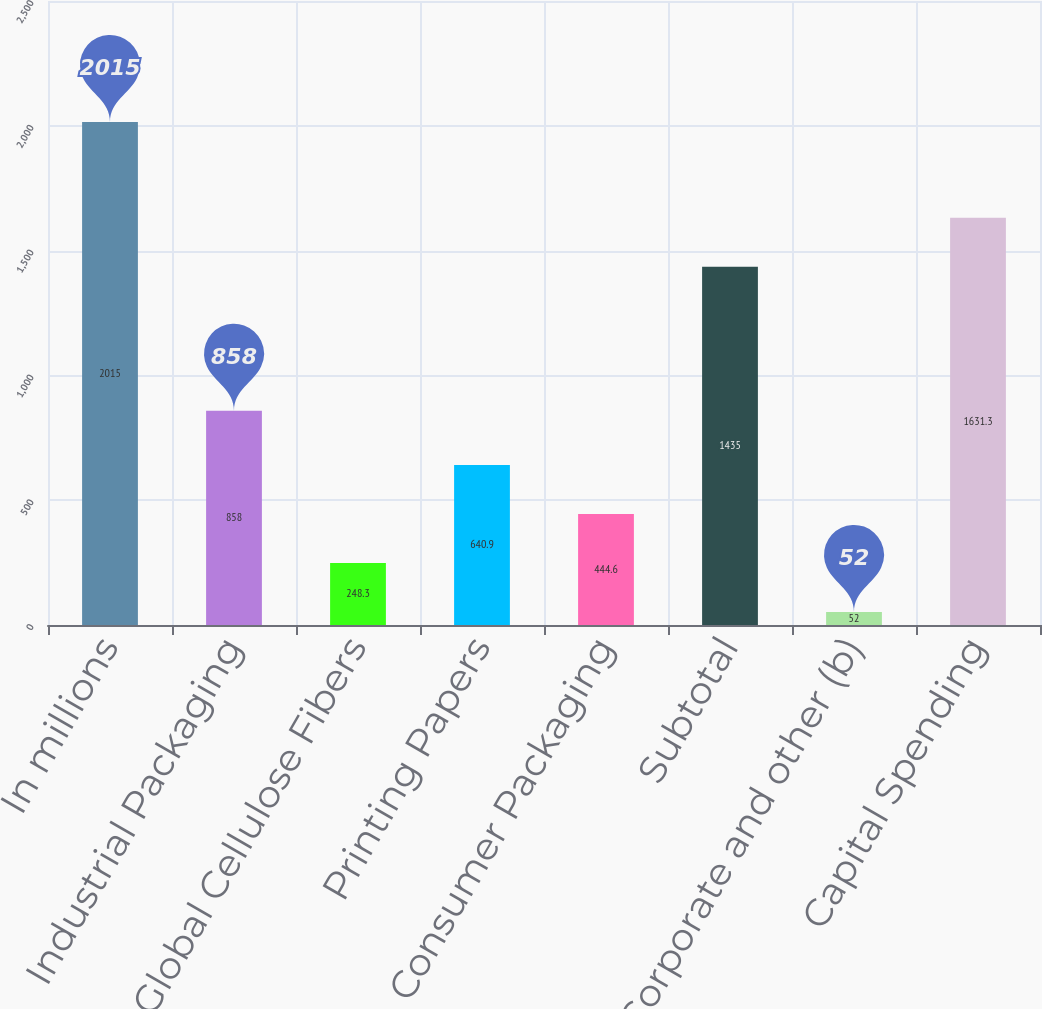Convert chart. <chart><loc_0><loc_0><loc_500><loc_500><bar_chart><fcel>In millions<fcel>Industrial Packaging<fcel>Global Cellulose Fibers<fcel>Printing Papers<fcel>Consumer Packaging<fcel>Subtotal<fcel>Corporate and other (b)<fcel>Capital Spending<nl><fcel>2015<fcel>858<fcel>248.3<fcel>640.9<fcel>444.6<fcel>1435<fcel>52<fcel>1631.3<nl></chart> 